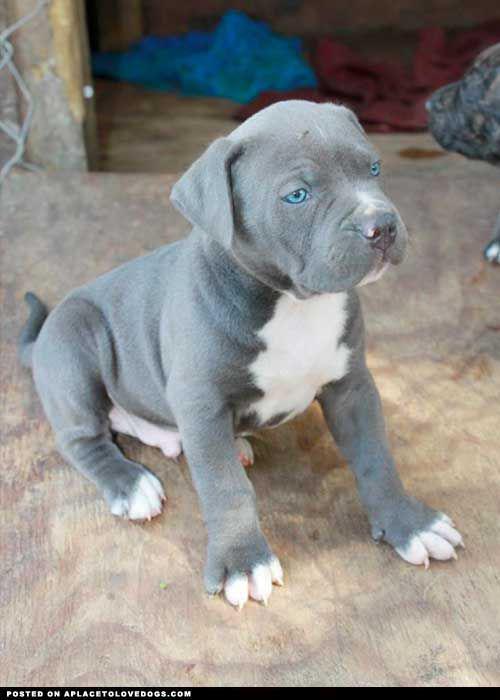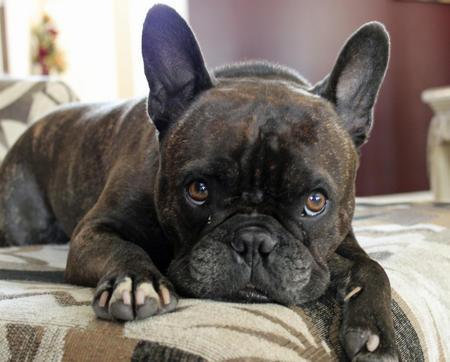The first image is the image on the left, the second image is the image on the right. Assess this claim about the two images: "One of the dogs has blue eyes.". Correct or not? Answer yes or no. Yes. The first image is the image on the left, the second image is the image on the right. Considering the images on both sides, is "Both dogs are looking at the camera." valid? Answer yes or no. No. 